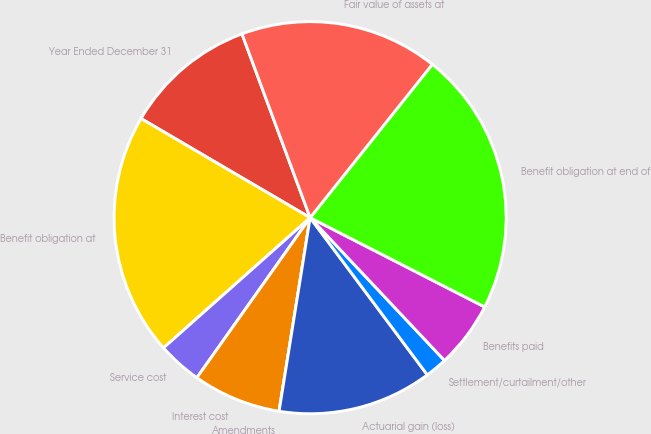Convert chart to OTSL. <chart><loc_0><loc_0><loc_500><loc_500><pie_chart><fcel>Year Ended December 31<fcel>Benefit obligation at<fcel>Service cost<fcel>Interest cost<fcel>Amendments<fcel>Actuarial gain (loss)<fcel>Settlement/curtailment/other<fcel>Benefits paid<fcel>Benefit obligation at end of<fcel>Fair value of assets at<nl><fcel>10.91%<fcel>20.0%<fcel>3.64%<fcel>7.27%<fcel>0.0%<fcel>12.73%<fcel>1.82%<fcel>5.46%<fcel>21.82%<fcel>16.36%<nl></chart> 